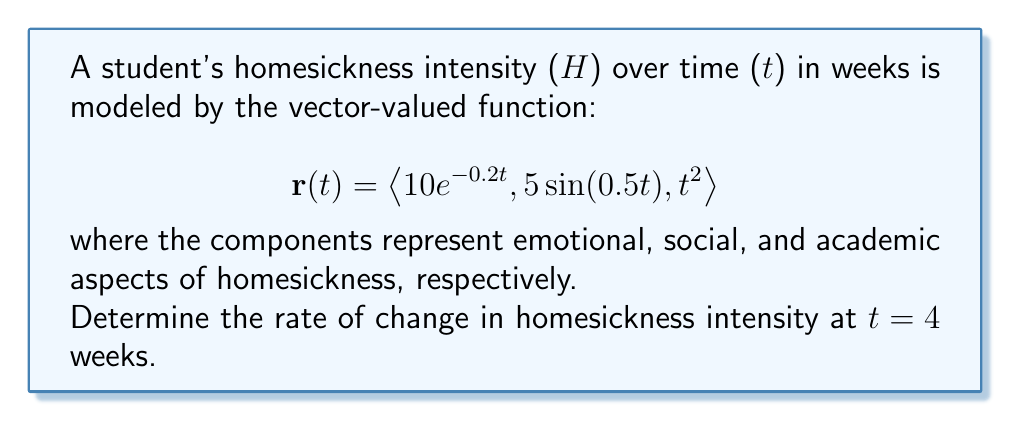Can you solve this math problem? To find the rate of change in homesickness intensity, we need to calculate the derivative of the vector-valued function $\mathbf{r}(t)$ and evaluate it at t = 4 weeks.

Step 1: Calculate the derivative of $\mathbf{r}(t)$
$$\mathbf{r}'(t) = \langle \frac{d}{dt}(10e^{-0.2t}), \frac{d}{dt}(5\sin(0.5t)), \frac{d}{dt}(t^2) \rangle$$

Step 2: Evaluate each component
1. $\frac{d}{dt}(10e^{-0.2t}) = -2e^{-0.2t}$
2. $\frac{d}{dt}(5\sin(0.5t)) = 2.5\cos(0.5t)$
3. $\frac{d}{dt}(t^2) = 2t$

Step 3: Write the derivative vector
$$\mathbf{r}'(t) = \langle -2e^{-0.2t}, 2.5\cos(0.5t), 2t \rangle$$

Step 4: Evaluate $\mathbf{r}'(t)$ at t = 4
$$\mathbf{r}'(4) = \langle -2e^{-0.8}, 2.5\cos(2), 8 \rangle$$

Step 5: Calculate the values
1. $-2e^{-0.8} \approx -0.90$
2. $2.5\cos(2) \approx -1.92$
3. $8$

Therefore, the rate of change in homesickness intensity at t = 4 weeks is:
$$\mathbf{r}'(4) \approx \langle -0.90, -1.92, 8 \rangle$$
Answer: $\langle -0.90, -1.92, 8 \rangle$ 